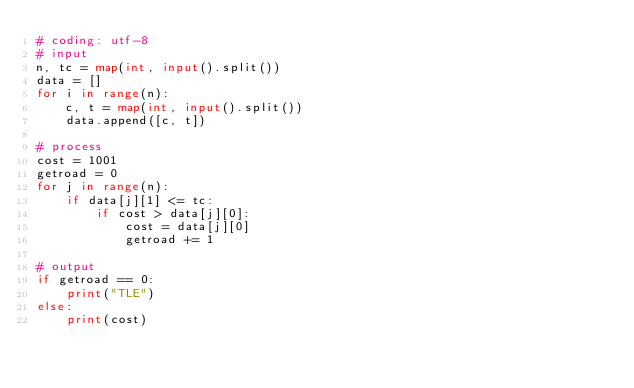<code> <loc_0><loc_0><loc_500><loc_500><_Python_># coding: utf-8
# input
n, tc = map(int, input().split())
data = []
for i in range(n):
    c, t = map(int, input().split())
    data.append([c, t])

# process
cost = 1001
getroad = 0
for j in range(n):
    if data[j][1] <= tc:
        if cost > data[j][0]:
            cost = data[j][0]
            getroad += 1

# output
if getroad == 0:
    print("TLE")
else:
    print(cost)
</code> 